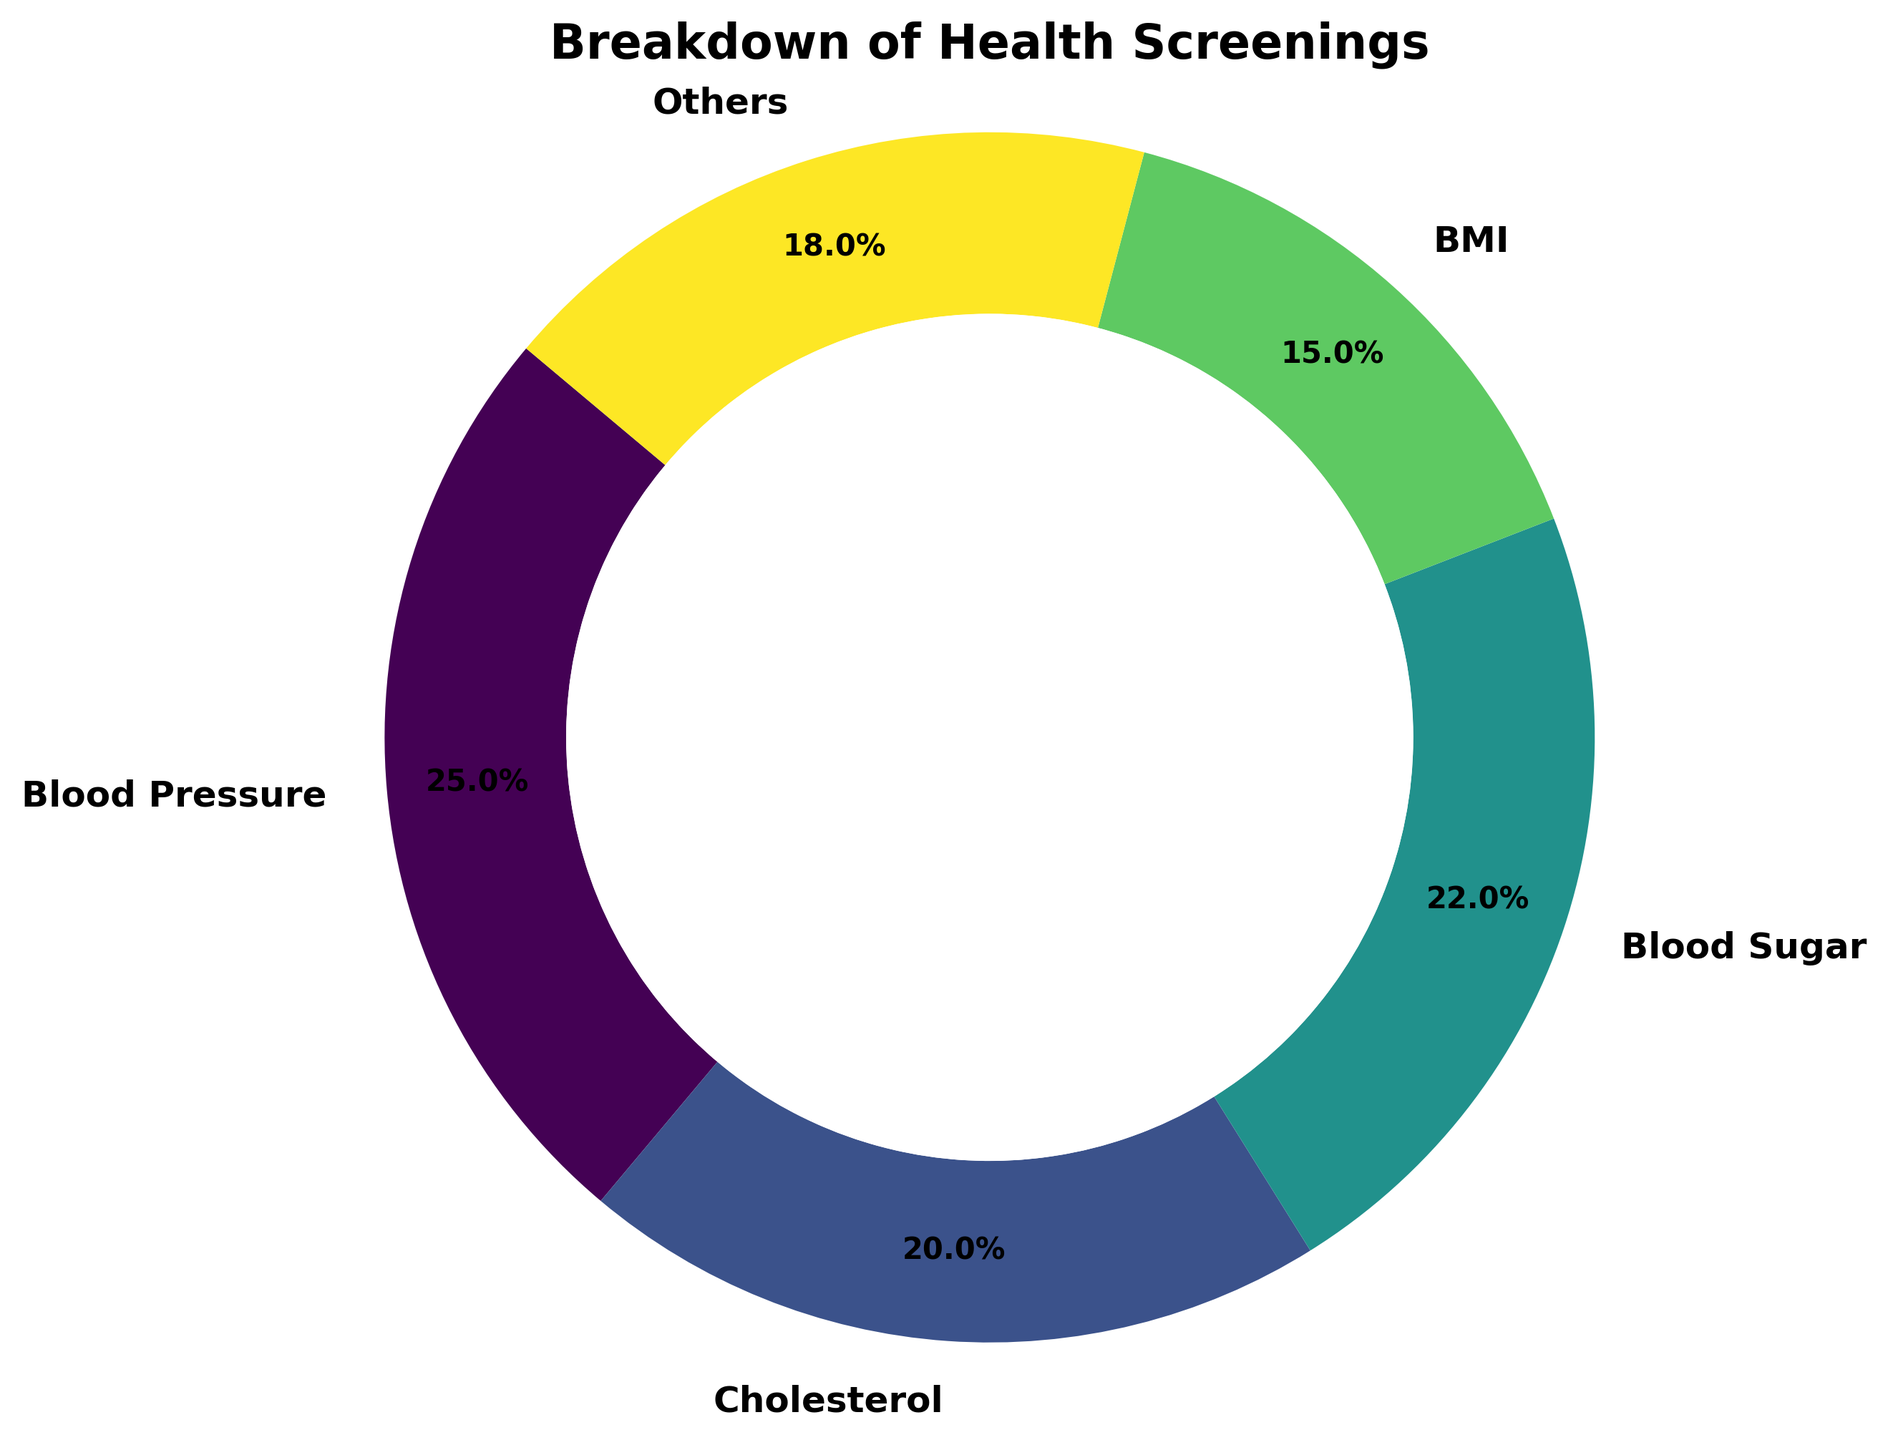What percentage of health screenings are for Blood Pressure? Blood Pressure occupies a segment in the ring chart with a label indicating 25%.
Answer: 25% How do the percentages for Cholesterol and Blood Sugar screenings compare? Cholesterol screenings are 20% and Blood Sugar screenings are 22%, making Blood Sugar slightly higher.
Answer: Blood Sugar is higher Which category represents the smallest percentage of health screenings? The chart shows 15% for BMI, which is the smallest segment compared to the others.
Answer: BMI What's the combined percentage for Blood Sugar and Blood Pressure screenings? Blood Sugar is 22% and Blood Pressure is 25%. Summing them gives 22% + 25% = 47%.
Answer: 47% Is the percentage of screening for Others greater or less than Cholesterol? Others is 18%, whereas Cholesterol is 20%, making Others less than Cholesterol.
Answer: Less What's the difference in percentage between the highest and lowest categories? The highest category is Blood Pressure at 25%, and the lowest is BMI at 15%. The difference is 25% - 15% = 10%.
Answer: 10% By how much does the percentage of BMI screenings differ from that of Blood Sugar screenings? Blood Sugar is 22% and BMI is 15%. The difference is 22% - 15% = 7%.
Answer: 7% Which health screening category has a percentage closest to one-fifth of the total? One-fifth of 100% is 20%. Cholesterol has a percentage of 20%, which matches one-fifth exactly.
Answer: Cholesterol 